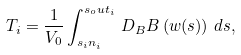<formula> <loc_0><loc_0><loc_500><loc_500>T _ { i } = \frac { 1 } { V _ { 0 } } \int _ { { s _ { i } n } _ { i } } ^ { { s _ { o } u t } _ { i } } \, D _ { B } B \left ( w ( s ) \right ) \, d s ,</formula> 